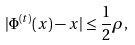Convert formula to latex. <formula><loc_0><loc_0><loc_500><loc_500>| \Phi ^ { ( t ) } ( x ) - x | \leq \frac { 1 } { 2 } \rho ,</formula> 